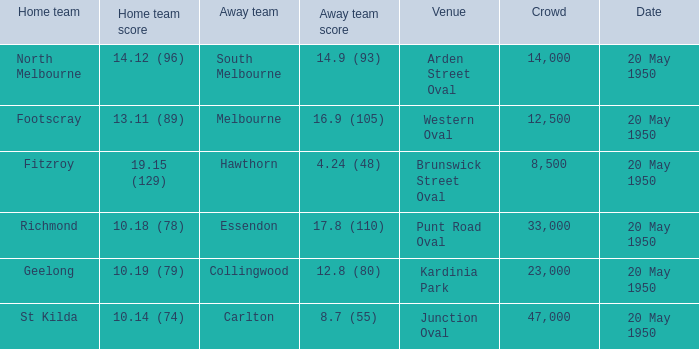9 (93)? Arden Street Oval. 